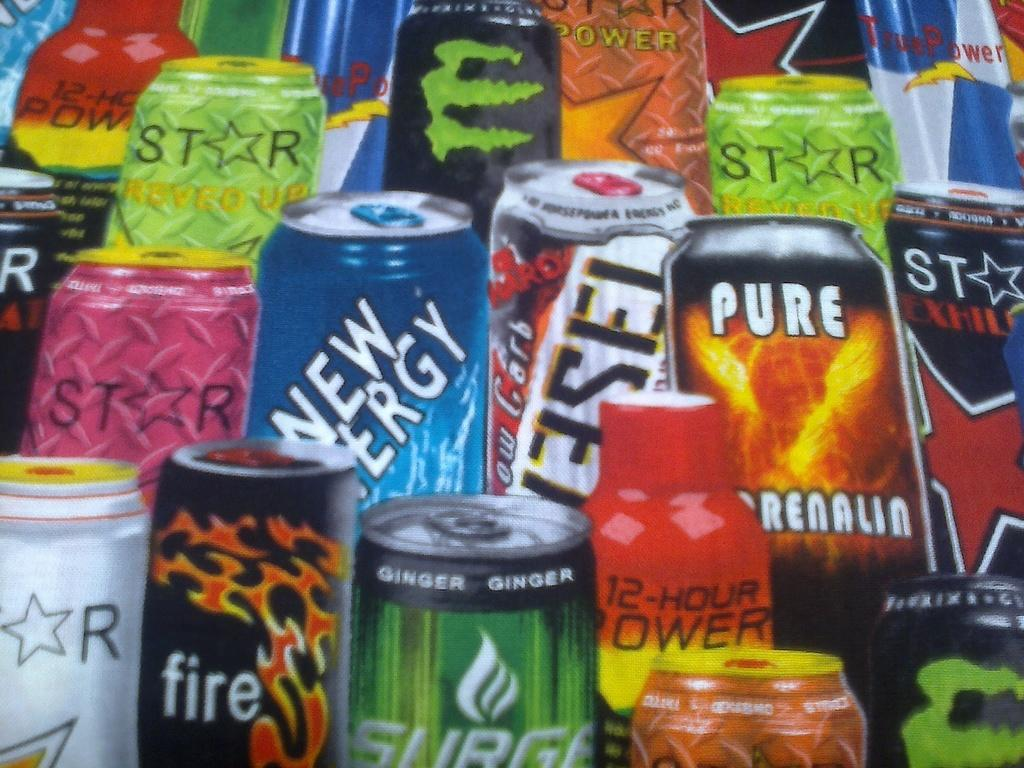<image>
Render a clear and concise summary of the photo. A stack of energy drinks from different brands are shown together. 